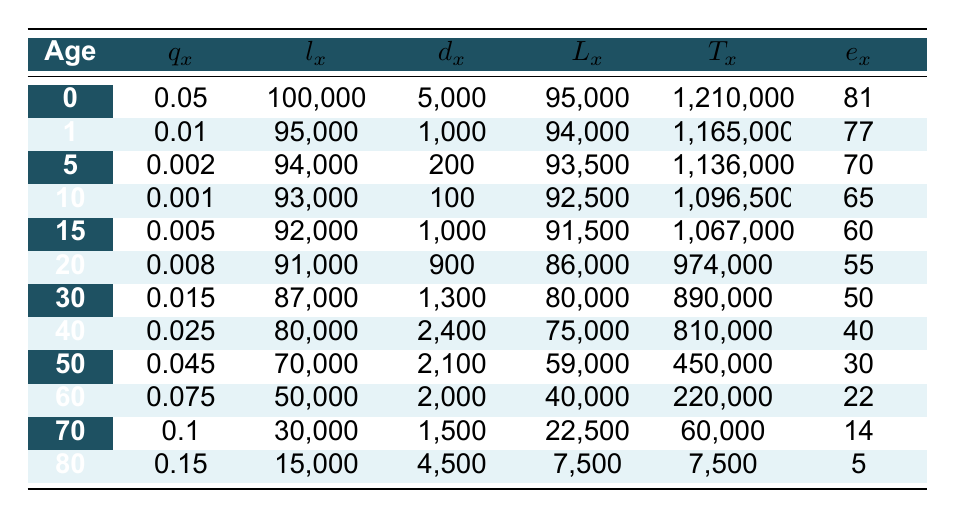What is the life expectancy at age 0? From the table, under the column "e_x" at age 0, the value is 81 years. This means that the average life expectancy for a newborn in the Dominican Republic is 81 years.
Answer: 81 years What is the difference in the number of survivors at age 50 and age 40? Looking at the "l_x" values, at age 50 there are 70,000 survivors, and at age 40 there are 80,000 survivors. The difference is 80,000 - 70,000 = 10,000.
Answer: 10,000 Is the death rate at age 60 higher than at age 50? The death rate is indicated by "q_x." At age 60, the q_x is 0.075, while at age 50, it is 0.045. Since 0.075 is greater than 0.045, the death rate at age 60 is indeed higher.
Answer: Yes What is the average life expectancy for people aged 70? According to the table, the life expectancy (e_x) at age 70 is 14 years. This means that an individual who reaches 70 years of age can expect to live an average of 14 more years.
Answer: 14 years How many people die between the ages of 40 and 50? To find the number of deaths between ages 40 and 50, we look at the "d_x" values for age 40 (2,400) and for age 50 (2,100). The total is 2,400 + 2,100 = 4,500.
Answer: 4,500 What percentage of the population smokes? The lifestyle factors section states that 30% of the population smokes. This percentage indicates a significant portion of the population engages in this lifestyle choice.
Answer: 30% How many more years can a 60-year-old expect to live compared to a 70-year-old? The life expectancy for a 60-year-old is 22 years, and for a 70-year-old, it is 14 years. The difference is 22 - 14 = 8 years. Thus, a 60-year-old can expect to live 8 years longer than a 70-year-old.
Answer: 8 years Is the access to healthcare services above or below 50% in the Dominican Republic? According to the lifestyle factors, 70% of the population has access to healthcare services, which is above 50%.
Answer: Above 50% What is the total number of individuals surviving from birth to age 80? In the table, the number of survivors at age 80 (l_x) is 15,000, which indicates the total number of individuals from a cohort who survive from birth and reach 80 years of age.
Answer: 15,000 